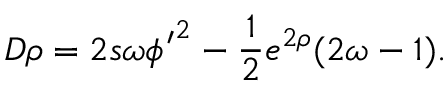<formula> <loc_0><loc_0><loc_500><loc_500>D \rho = 2 s \omega { \phi ^ { \prime } } ^ { 2 } - \frac { 1 } { 2 } e ^ { 2 \rho } ( 2 \omega - 1 ) .</formula> 